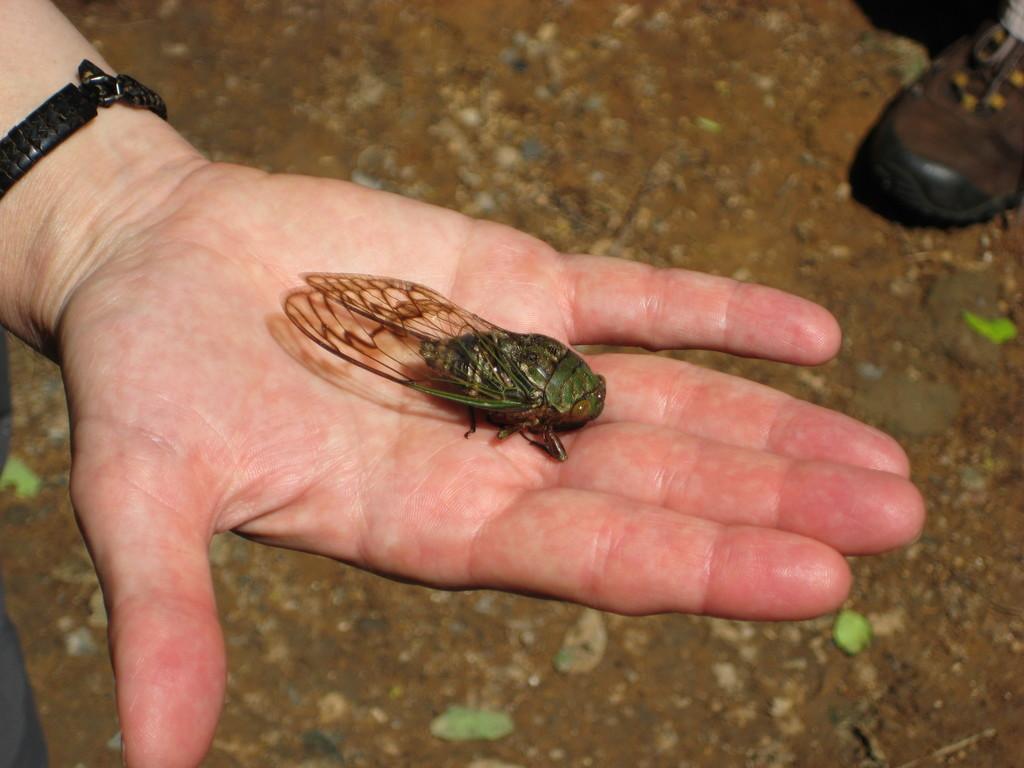Describe this image in one or two sentences. In the image there is a hand, in the hand there is a insect. In the top right corner of the image there is shoe. 